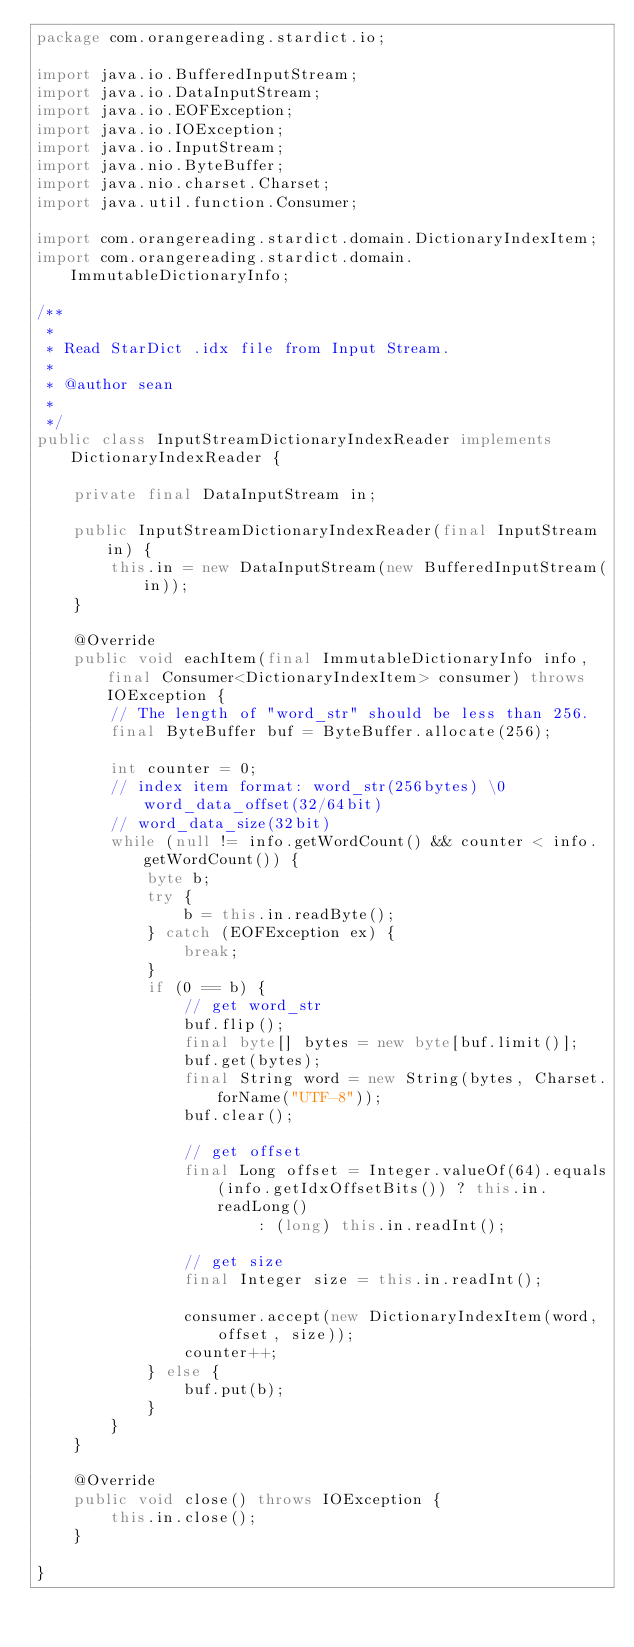<code> <loc_0><loc_0><loc_500><loc_500><_Java_>package com.orangereading.stardict.io;

import java.io.BufferedInputStream;
import java.io.DataInputStream;
import java.io.EOFException;
import java.io.IOException;
import java.io.InputStream;
import java.nio.ByteBuffer;
import java.nio.charset.Charset;
import java.util.function.Consumer;

import com.orangereading.stardict.domain.DictionaryIndexItem;
import com.orangereading.stardict.domain.ImmutableDictionaryInfo;

/**
 * 
 * Read StarDict .idx file from Input Stream.
 * 
 * @author sean
 *
 */
public class InputStreamDictionaryIndexReader implements DictionaryIndexReader {

	private final DataInputStream in;

	public InputStreamDictionaryIndexReader(final InputStream in) {
		this.in = new DataInputStream(new BufferedInputStream(in));
	}

	@Override
	public void eachItem(final ImmutableDictionaryInfo info, final Consumer<DictionaryIndexItem> consumer) throws IOException {
		// The length of "word_str" should be less than 256.
		final ByteBuffer buf = ByteBuffer.allocate(256);

		int counter = 0;
		// index item format: word_str(256bytes) \0 word_data_offset(32/64bit)
		// word_data_size(32bit)
		while (null != info.getWordCount() && counter < info.getWordCount()) {
			byte b;
			try {
				b = this.in.readByte();
			} catch (EOFException ex) {
				break;
			}
			if (0 == b) {
				// get word_str
				buf.flip();
				final byte[] bytes = new byte[buf.limit()];
				buf.get(bytes);
				final String word = new String(bytes, Charset.forName("UTF-8"));
				buf.clear();

				// get offset
				final Long offset = Integer.valueOf(64).equals(info.getIdxOffsetBits()) ? this.in.readLong()
						: (long) this.in.readInt();

				// get size
				final Integer size = this.in.readInt();

				consumer.accept(new DictionaryIndexItem(word, offset, size));
				counter++;
			} else {
				buf.put(b);
			}
		}
	}

	@Override
	public void close() throws IOException {
		this.in.close();
	}

}
</code> 